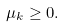Convert formula to latex. <formula><loc_0><loc_0><loc_500><loc_500>\mu _ { k } \geq 0 .</formula> 